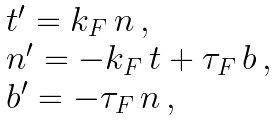<formula> <loc_0><loc_0><loc_500><loc_500>\begin{array} { l } { t } ^ { \prime } = k _ { F } \, { n } \, , \\ { n } ^ { \prime } = - k _ { F } \, { t } + \tau _ { F } \, { b } \, , \\ { b } ^ { \prime } = - \tau _ { F } \, { n } \, , \end{array}</formula> 